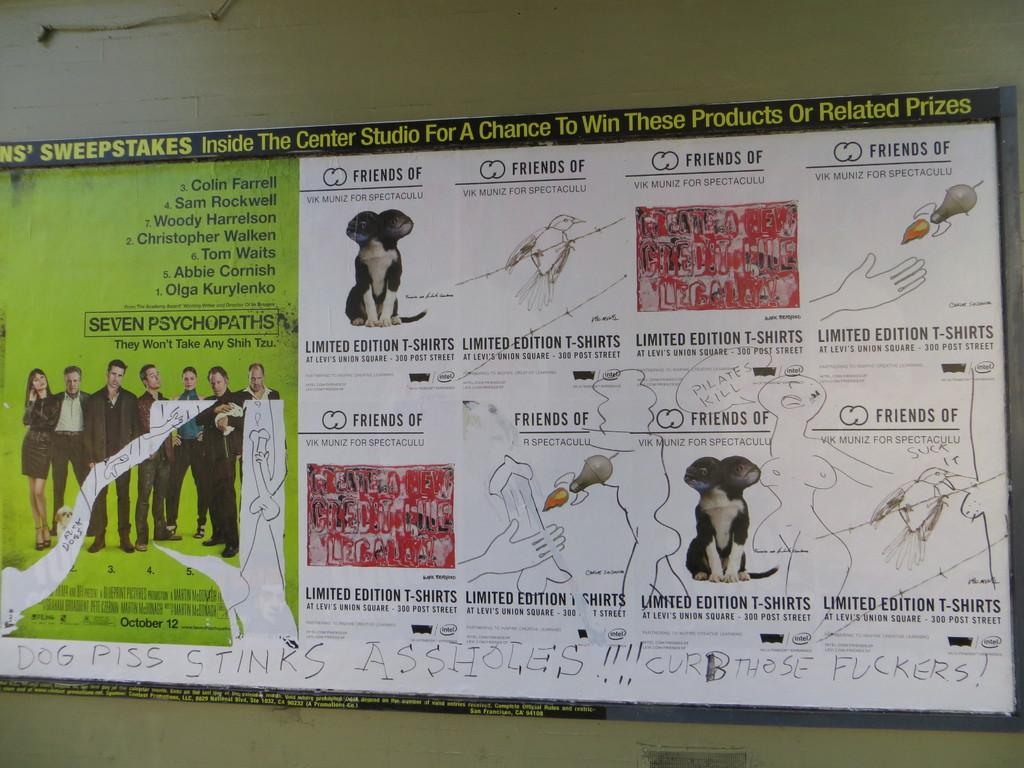<image>
Present a compact description of the photo's key features. A sign for a movie called Seven Psychopaths has had graffiti written on it. 